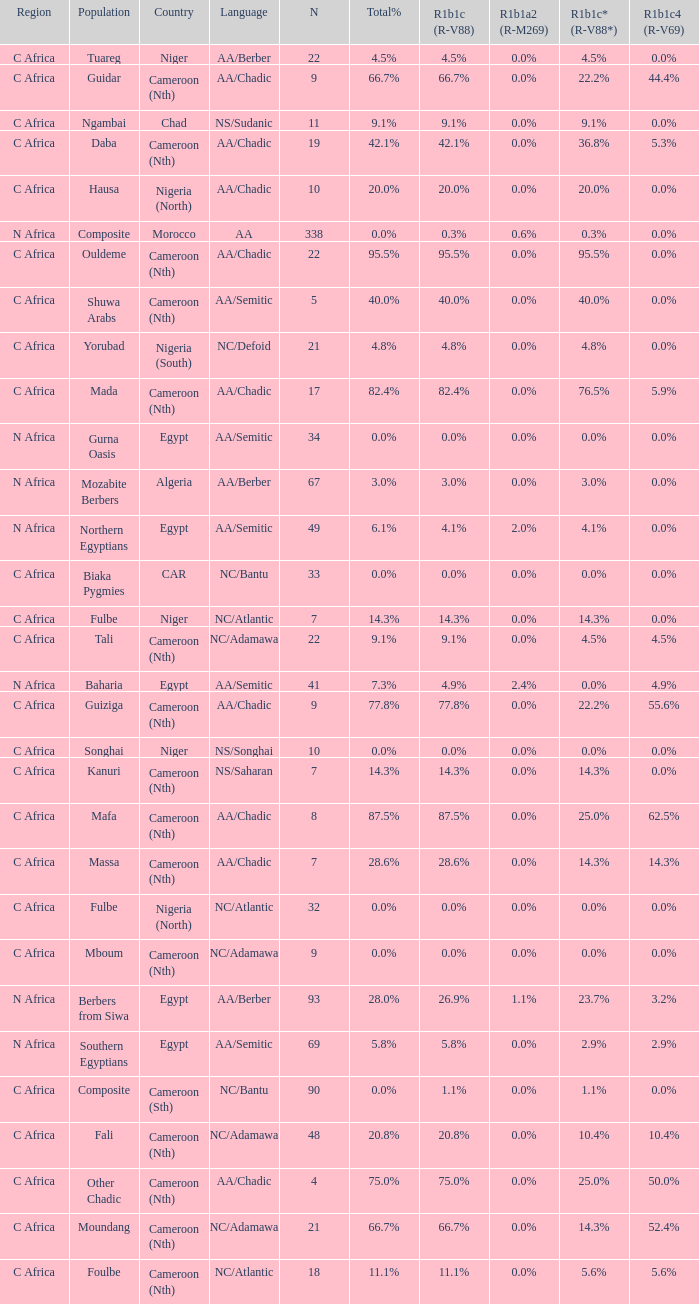What languages are spoken in Niger with r1b1c (r-v88) of 0.0%? NS/Songhai. 